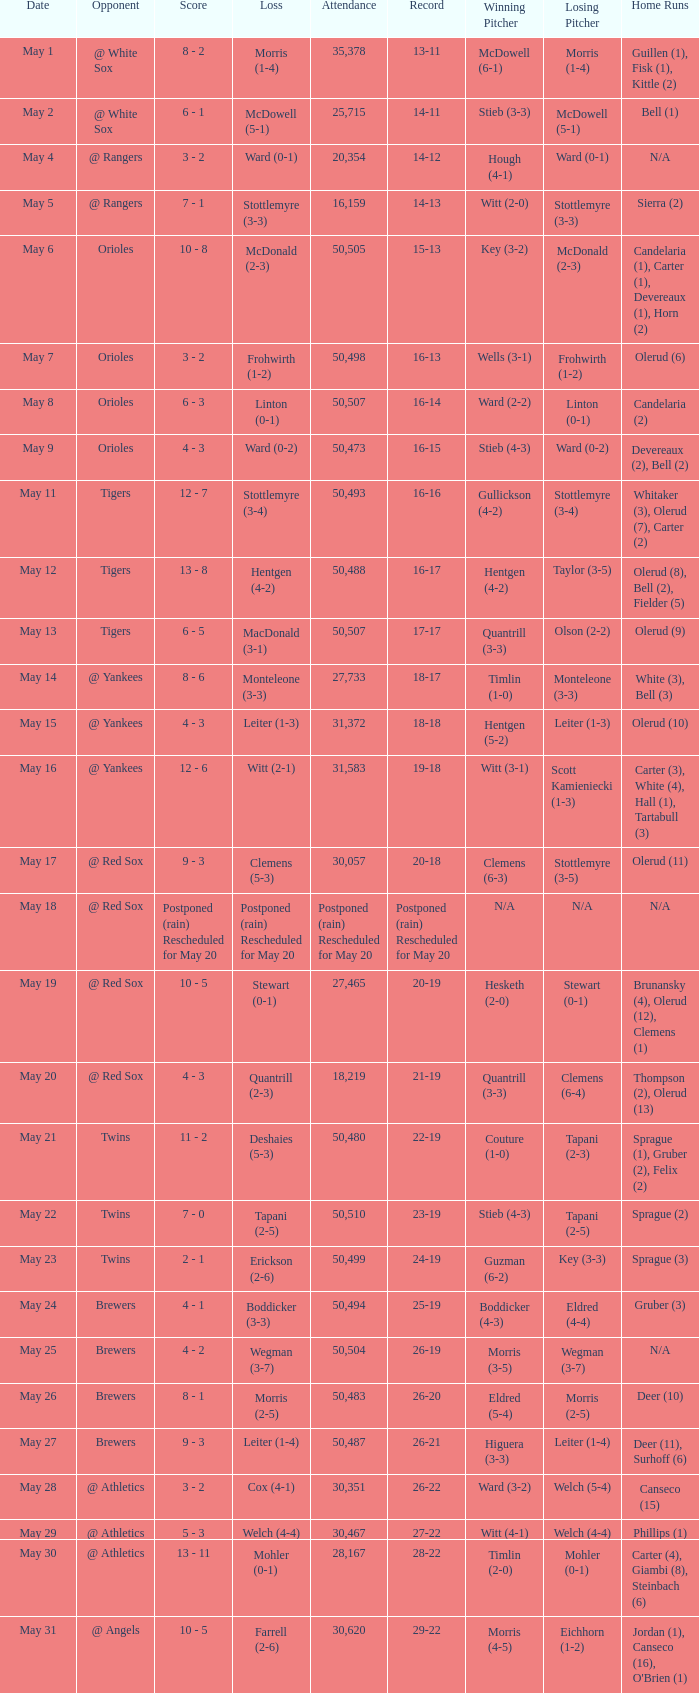What was the score of the game played on May 9? 4 - 3. 